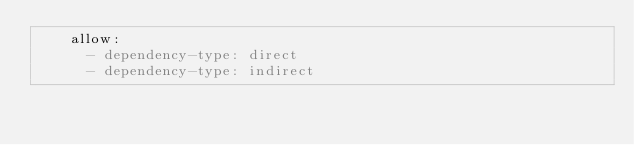<code> <loc_0><loc_0><loc_500><loc_500><_YAML_>    allow:
      - dependency-type: direct
      - dependency-type: indirect
</code> 